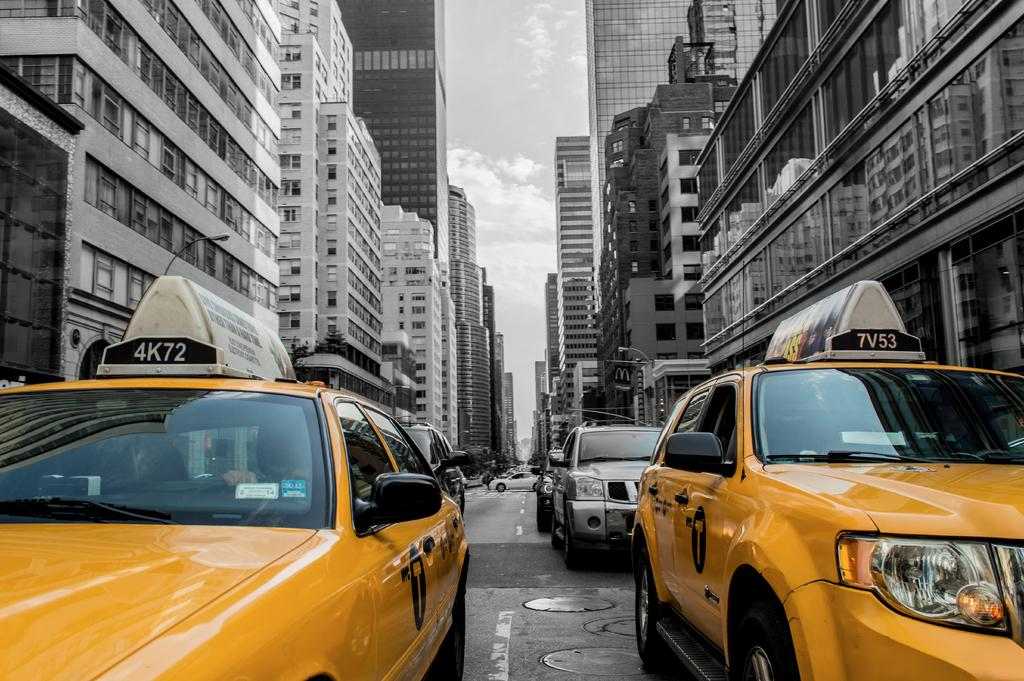Provide a one-sentence caption for the provided image. a few cars with the numbers and letters 7V53 on it. 